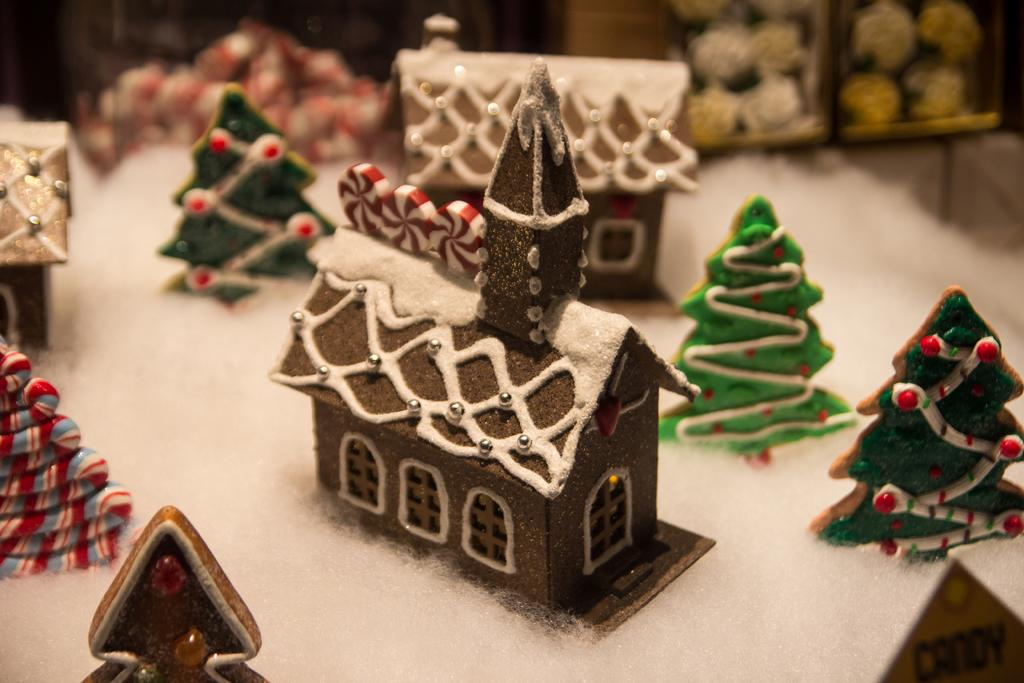What type of objects are present in the image that resemble trees? There are small cardboard trees in the image. What other structures can be seen in the image? There are tiny homes in the image. How would you describe the environment depicted in the image? The image depicts a snowy environment. How many clocks are hanging on the walls of the tiny homes in the image? There are no clocks visible in the image; it only shows small cardboard trees and tiny homes in a snowy environment. 